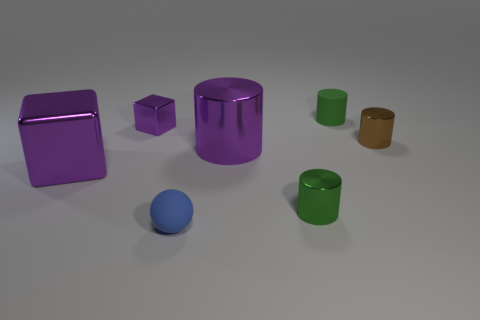Subtract all big shiny cylinders. How many cylinders are left? 3 Subtract all cyan cubes. How many green cylinders are left? 2 Subtract all green cylinders. How many cylinders are left? 2 Add 2 big green cylinders. How many objects exist? 9 Subtract all cylinders. How many objects are left? 3 Add 7 purple metal cylinders. How many purple metal cylinders are left? 8 Add 1 large cubes. How many large cubes exist? 2 Subtract 0 red cubes. How many objects are left? 7 Subtract all green spheres. Subtract all blue cubes. How many spheres are left? 1 Subtract all tiny brown rubber cylinders. Subtract all small cylinders. How many objects are left? 4 